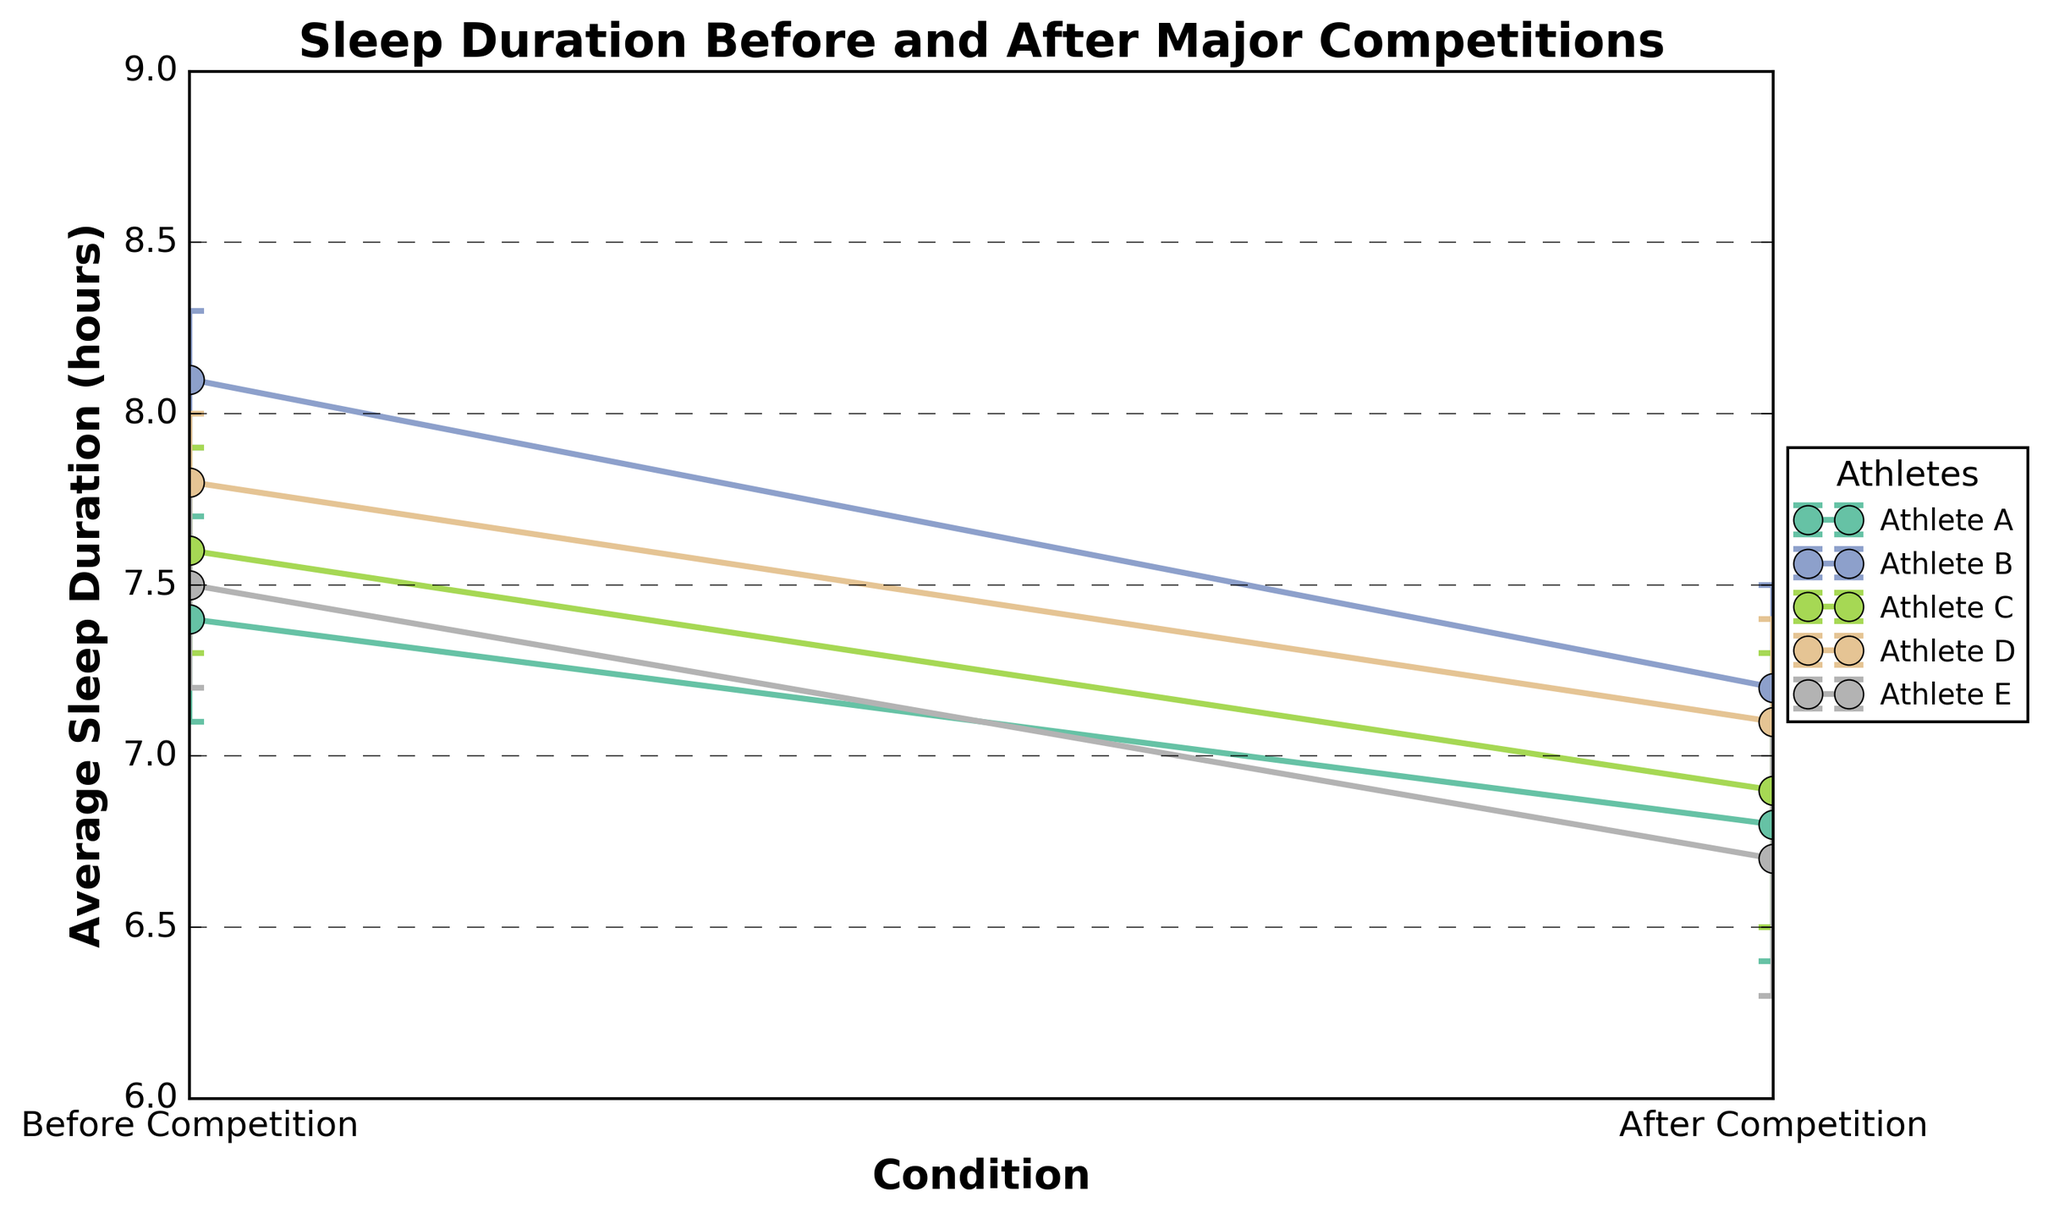What is the title of the plot? The title is written at the top of the plot in bold font. It states "Sleep Duration Before and After Major Competitions."
Answer: Sleep Duration Before and After Major Competitions What are the labels on the x-axis? The x-axis labels are shown at the bottom of the plot indicating the conditions; they are "Before Competition" and "After Competition."
Answer: Before Competition, After Competition Which athlete has the highest average sleep duration before the competition? The average sleep duration before the competition is represented by the points at the x-axis labeled "Before Competition." Athlete B has the highest value of 8.1 hours.
Answer: Athlete B What is the difference in average sleep duration before and after the competition for Athlete D? For Athlete D, before the competition the average sleep duration is 7.8 hours, and after it is 7.1 hours. The difference is calculated as 7.8 - 7.1 = 0.7 hours.
Answer: 0.7 hours Which athlete has the smallest decrease in sleep duration after the competition? By examining the lines connecting the before and after competition points for each athlete, Athlete D has the smallest decrease (7.8 to 7.1, a decrease of 0.7 hours).
Answer: Athlete D What is the range of sleep durations before the competition? The range is determined by the difference between the highest and lowest values before the competition. The highest value is 8.1 hours (Athlete B) and the lowest is 7.4 hours (Athlete A), so the range is 8.1 - 7.4 = 0.7 hours.
Answer: 0.7 hours What are the standard errors for Athlete C before and after the competition? The points for Athlete C on the plot include error bars representing the standard errors. The standard error before the competition is 0.3 hours, and after the competition is 0.4 hours.
Answer: 0.3 hours, 0.4 hours Which condition generally has a lower average sleep duration across all athletes? By comparing the average sleep duration points, the points after the competition are generally lower across all athletes.
Answer: After Competition How much does Athlete A's sleep duration decrease after the competition, considering standard errors? Athlete A’s average sleep duration decreases from 7.4 to 6.8 hours. Including standard errors, it goes from (7.4 ± 0.3) to (6.8 ± 0.4). This means the change ranges from minimum 7.1 to 7.7 hours before, and from 6.4 to 7.2 hours after. The overlap indicates a plausible decrease of up to 0.6 hours, considering possible measurement variations.
Answer: Approx. 0.6 hours (considering overlap) Is there any athlete whose sleep duration does not show a significant decrease after the competition? Significant overlap in the error bars might indicate no significant decrease. Athlete D shows overlap between before (7.8, SE 0.2) and after (7.1, SE 0.3). So the decrease might not be significant in practical terms.
Answer: Athlete D 